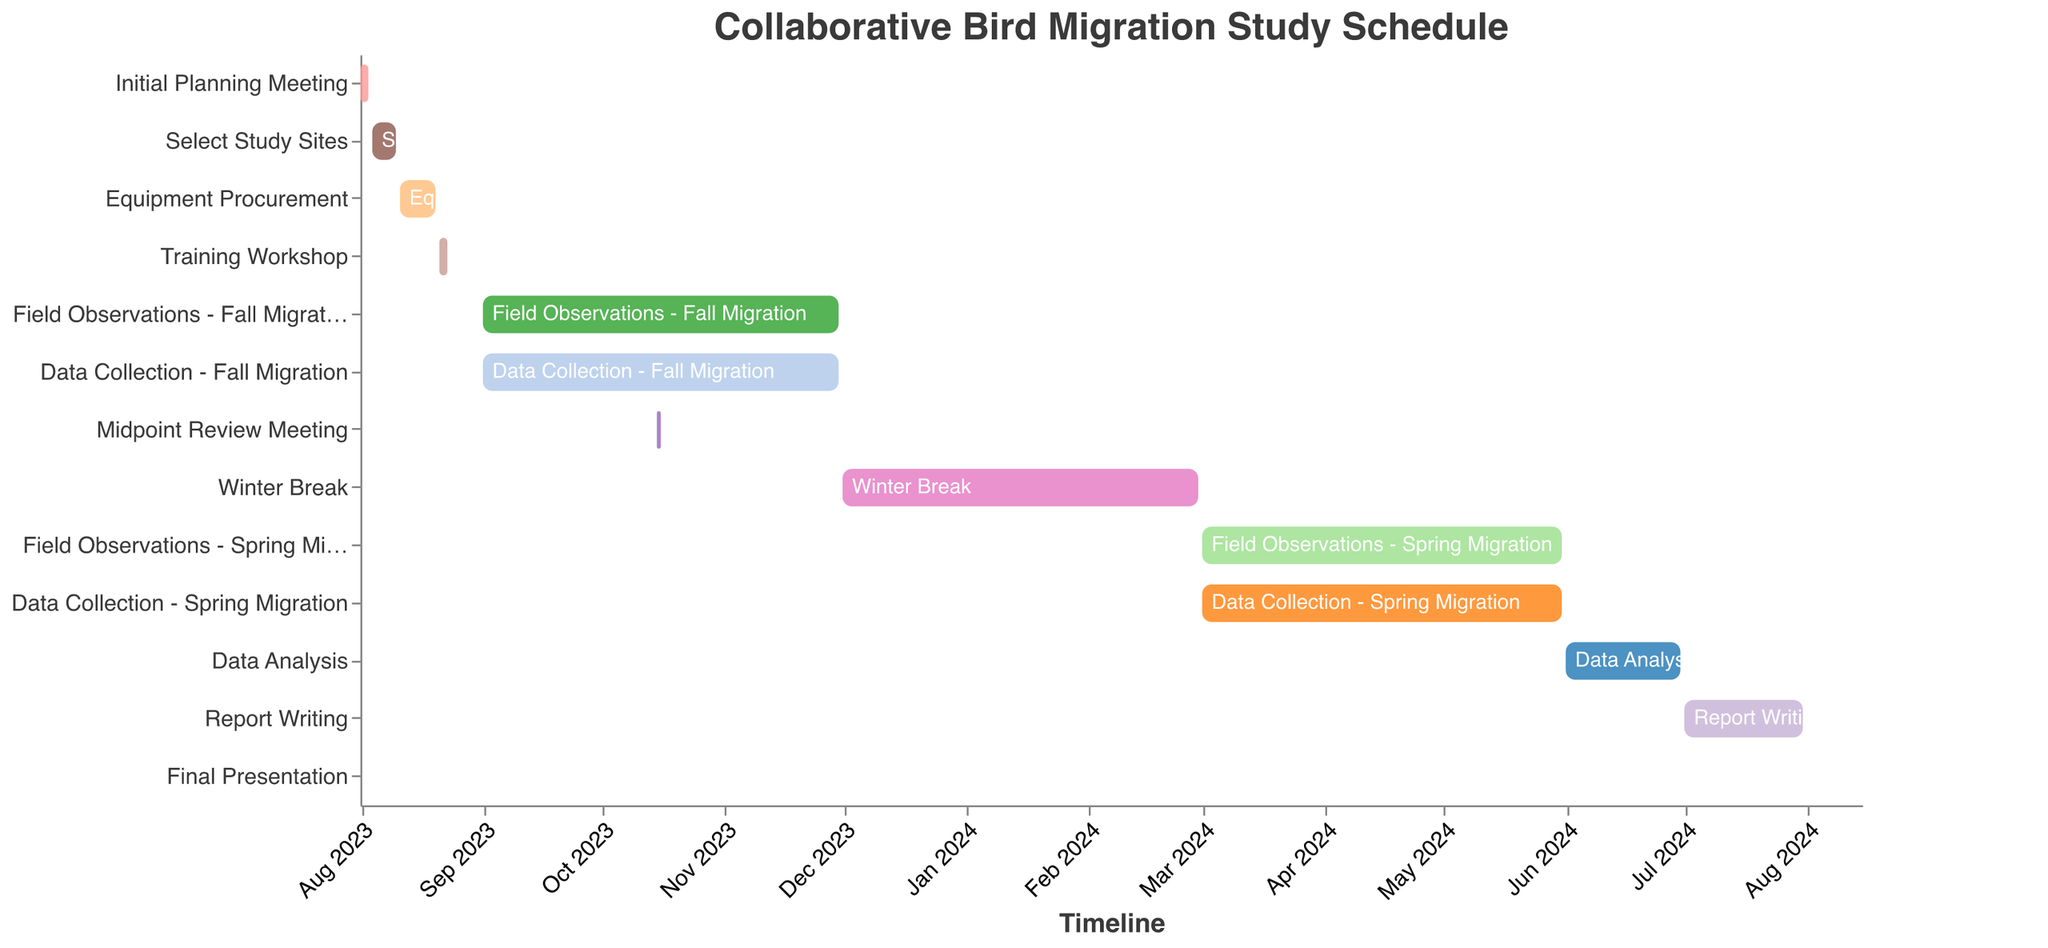What is the timeframe for Equipment Procurement? To find the timeframe for Equipment Procurement, look at its "Start Date" and "End Date" on the Gantt Chart to identify the start and end points.
Answer: August 11, 2023, to August 20, 2023 Which task is scheduled to take place around mid-October 2023? Look at the tasks around mid-October 2023 on the timeline. The task "Midpoint Review Meeting" fits this period, set around October 15, 2023, to October 16, 2023.
Answer: Midpoint Review Meeting How long does the Winter Break last? Calculate the duration by subtracting the "Start Date" from the "End Date" of the Winter Break. It's from December 1, 2023, to February 29, 2024.
Answer: 3 months What is the first task scheduled for March 2024? Locate March 2024 on the timeline and find the first task that starts in that period, which is "Field Observations - Spring Migration."
Answer: Field Observations - Spring Migration Which task happens concurrently with "Data Collection - Spring Migration"? Locate "Data Collection - Spring Migration" on the timeline, and see which tasks have overlapping dates. "Field Observations - Spring Migration" happens concurrently.
Answer: Field Observations - Spring Migration Which tasks extend over multiple months? Identify tasks that span more than one month based on the timeline. Examples include "Field Observations - Fall Migration" (September to November 2023), "Data Collection - Fall Migration" (September to November 2023), "Field Observations - Spring Migration" (March to May 2024), and "Data Collection - Spring Migration" (March to May 2024).
Answer: Field Observations - Fall Migration, Data Collection - Fall Migration, Field Observations - Spring Migration, Data Collection - Spring Migration What is the last task in the schedule? Look for the task that appears last on the timeline, which is "Final Presentation," ending on August 15, 2024.
Answer: Final Presentation How much time is allocated for the Training Workshop? Calculate the number of days between the "Start Date" and "End Date" for the Training Workshop. It runs from August 21, 2023, to August 23, 2023.
Answer: 3 days 